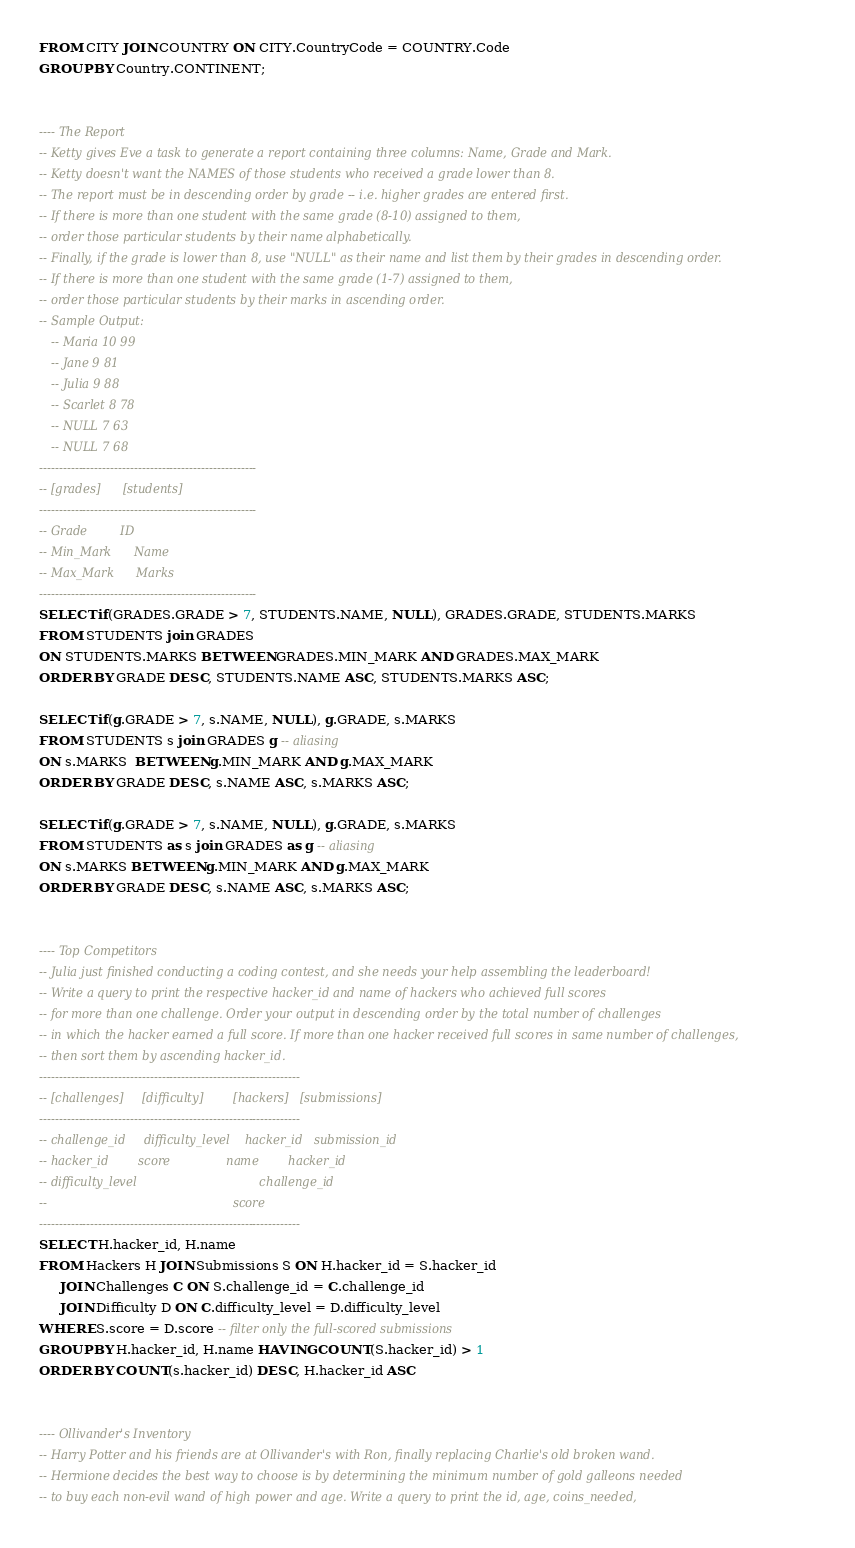<code> <loc_0><loc_0><loc_500><loc_500><_SQL_>FROM CITY JOIN COUNTRY ON CITY.CountryCode = COUNTRY.Code
GROUP BY Country.CONTINENT;


---- The Report
-- Ketty gives Eve a task to generate a report containing three columns: Name, Grade and Mark.
-- Ketty doesn't want the NAMES of those students who received a grade lower than 8.
-- The report must be in descending order by grade -- i.e. higher grades are entered first.
-- If there is more than one student with the same grade (8-10) assigned to them,
-- order those particular students by their name alphabetically.
-- Finally, if the grade is lower than 8, use "NULL" as their name and list them by their grades in descending order.
-- If there is more than one student with the same grade (1-7) assigned to them,
-- order those particular students by their marks in ascending order.
-- Sample Output:
   -- Maria 10 99
   -- Jane 9 81
   -- Julia 9 88 
   -- Scarlet 8 78
   -- NULL 7 63
   -- NULL 7 68
-------------------------------------------------------
-- [grades]      [students]
-------------------------------------------------------
-- Grade         ID 
-- Min_Mark      Name 
-- Max_Mark      Marks 
-------------------------------------------------------
SELECT if(GRADES.GRADE > 7, STUDENTS.NAME, NULL), GRADES.GRADE, STUDENTS.MARKS
FROM STUDENTS join GRADES
ON STUDENTS.MARKS BETWEEN GRADES.MIN_MARK AND GRADES.MAX_MARK
ORDER BY GRADE DESC, STUDENTS.NAME ASC, STUDENTS.MARKS ASC;

SELECT if(g.GRADE > 7, s.NAME, NULL), g.GRADE, s.MARKS
FROM STUDENTS s join GRADES g -- aliasing
ON s.MARKS  BETWEEN g.MIN_MARK AND g.MAX_MARK
ORDER BY GRADE DESC, s.NAME ASC, s.MARKS ASC;

SELECT if(g.GRADE > 7, s.NAME, NULL), g.GRADE, s.MARKS
FROM STUDENTS as s join GRADES as g -- aliasing
ON s.MARKS BETWEEN g.MIN_MARK AND g.MAX_MARK
ORDER BY GRADE DESC, s.NAME ASC, s.MARKS ASC;


---- Top Competitors
-- Julia just finished conducting a coding contest, and she needs your help assembling the leaderboard!
-- Write a query to print the respective hacker_id and name of hackers who achieved full scores
-- for more than one challenge. Order your output in descending order by the total number of challenges
-- in which the hacker earned a full score. If more than one hacker received full scores in same number of challenges,
-- then sort them by ascending hacker_id.
------------------------------------------------------------------
-- [challenges]     [difficulty]        [hackers]   [submissions] 
------------------------------------------------------------------
-- challenge_id     difficulty_level    hacker_id   submission_id
-- hacker_id        score               name        hacker_id
-- difficulty_level                                 challenge_id
--                                                  score
------------------------------------------------------------------
SELECT H.hacker_id, H.name
FROM Hackers H JOIN Submissions S ON H.hacker_id = S.hacker_id
     JOIN Challenges C ON S.challenge_id = C.challenge_id
     JOIN Difficulty D ON C.difficulty_level = D.difficulty_level
WHERE S.score = D.score -- filter only the full-scored submissions
GROUP BY H.hacker_id, H.name HAVING COUNT(S.hacker_id) > 1
ORDER BY COUNT(s.hacker_id) DESC, H.hacker_id ASC


---- Ollivander's Inventory
-- Harry Potter and his friends are at Ollivander's with Ron, finally replacing Charlie's old broken wand.
-- Hermione decides the best way to choose is by determining the minimum number of gold galleons needed
-- to buy each non-evil wand of high power and age. Write a query to print the id, age, coins_needed,</code> 